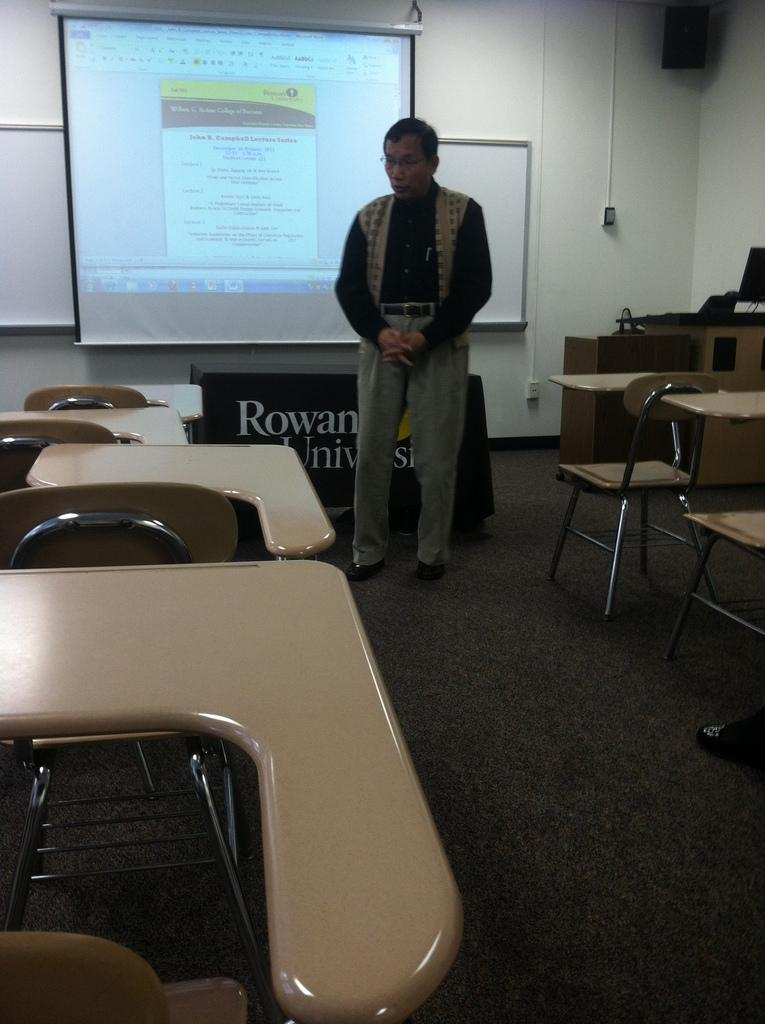What is on the wall in the image? There is a whiteboard on the wall in the image. Where is the whiteboard positioned in relation to the screen? The whiteboard is located at the backside of the screen. Can you describe the person in the image? There is a person standing in the image. What type of furniture is visible in the image? Chairs and tables are present in the image. What type of string is being used by the person in the image? There is no string visible in the image, and the person's actions are not described. How many dogs are present in the image? There are no dogs present in the image. 